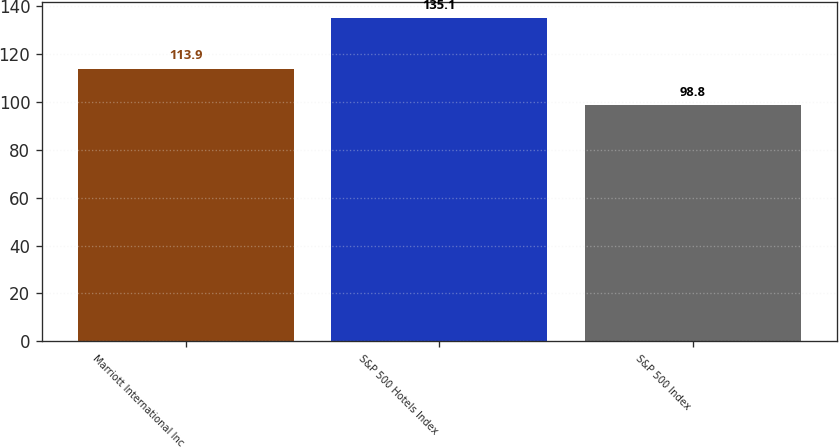Convert chart to OTSL. <chart><loc_0><loc_0><loc_500><loc_500><bar_chart><fcel>Marriott International Inc<fcel>S&P 500 Hotels Index<fcel>S&P 500 Index<nl><fcel>113.9<fcel>135.1<fcel>98.8<nl></chart> 